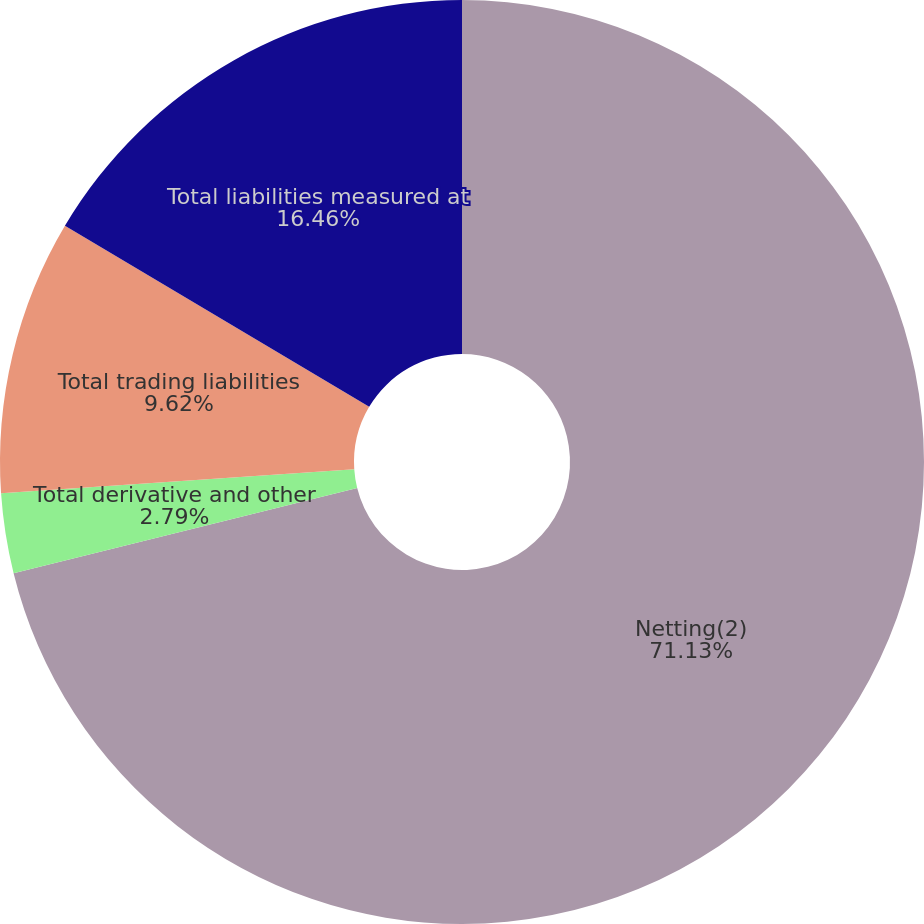Convert chart. <chart><loc_0><loc_0><loc_500><loc_500><pie_chart><fcel>Netting(2)<fcel>Total derivative and other<fcel>Total trading liabilities<fcel>Total liabilities measured at<nl><fcel>71.13%<fcel>2.79%<fcel>9.62%<fcel>16.46%<nl></chart> 